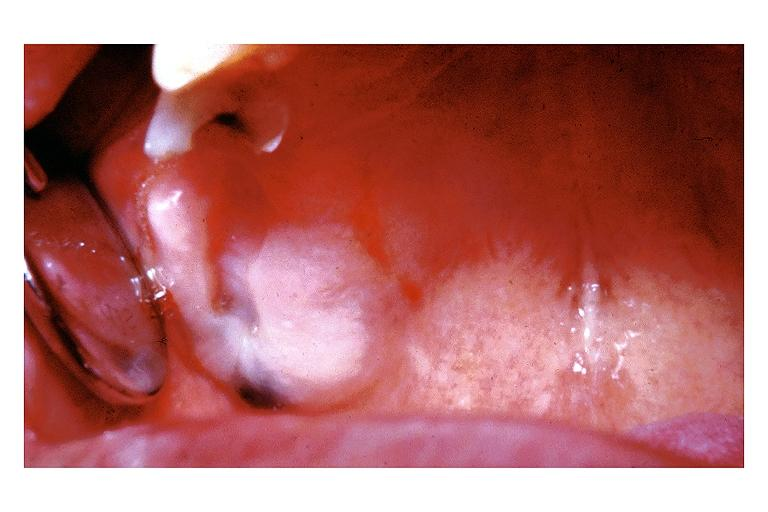s oral present?
Answer the question using a single word or phrase. Yes 